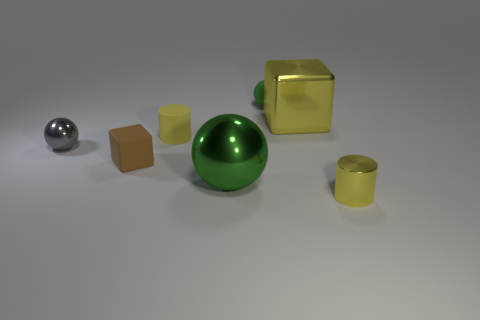What could be the purpose of arranging these objects like this? This arrangement could serve several purposes. It might be a simple artistic composition exploring form, color, and reflections, or it could be a set-up for a physics demonstration about materials and light interaction. Could you estimate the materials from which these objects might be made? The large green and small gray spheres seem to be made of a glossy material, likely plastic or polished metal. The yellow objects have a reflective surface, indicative of a metallic finish, while the tan cube looks to be of a matte material, possibly wood or plastic. 